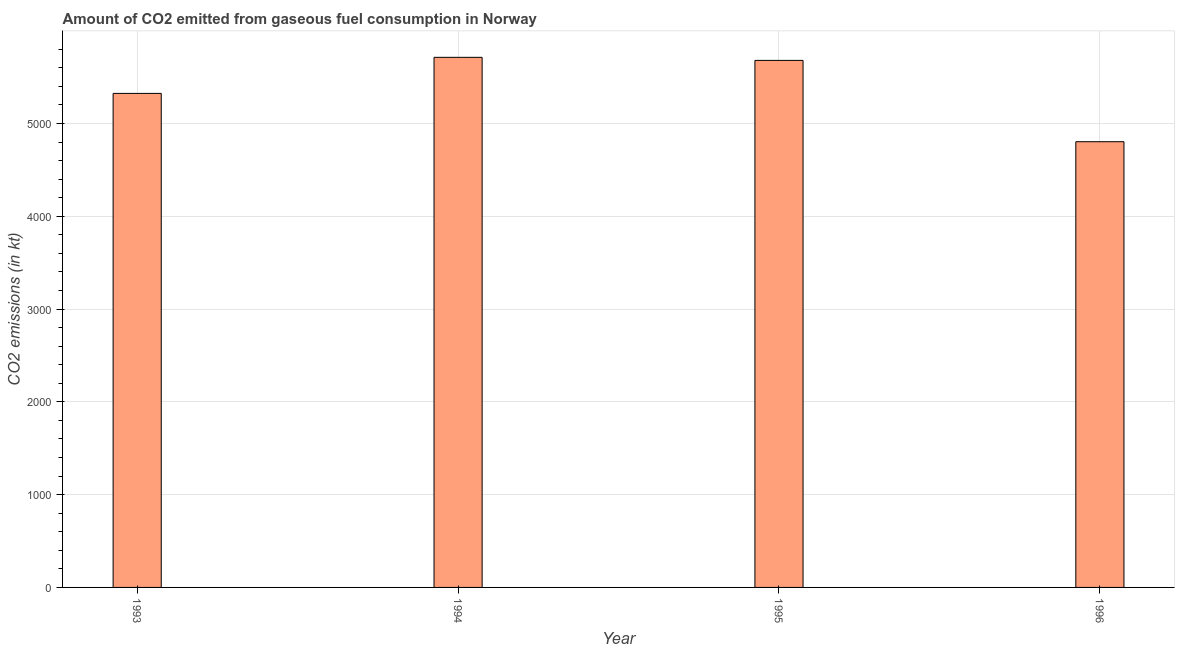What is the title of the graph?
Your response must be concise. Amount of CO2 emitted from gaseous fuel consumption in Norway. What is the label or title of the X-axis?
Offer a terse response. Year. What is the label or title of the Y-axis?
Ensure brevity in your answer.  CO2 emissions (in kt). What is the co2 emissions from gaseous fuel consumption in 1996?
Make the answer very short. 4803.77. Across all years, what is the maximum co2 emissions from gaseous fuel consumption?
Give a very brief answer. 5713.19. Across all years, what is the minimum co2 emissions from gaseous fuel consumption?
Offer a very short reply. 4803.77. In which year was the co2 emissions from gaseous fuel consumption maximum?
Ensure brevity in your answer.  1994. What is the sum of the co2 emissions from gaseous fuel consumption?
Your response must be concise. 2.15e+04. What is the difference between the co2 emissions from gaseous fuel consumption in 1993 and 1995?
Provide a succinct answer. -355.7. What is the average co2 emissions from gaseous fuel consumption per year?
Your answer should be compact. 5380.41. What is the median co2 emissions from gaseous fuel consumption?
Keep it short and to the point. 5502.33. In how many years, is the co2 emissions from gaseous fuel consumption greater than 400 kt?
Ensure brevity in your answer.  4. Do a majority of the years between 1995 and 1994 (inclusive) have co2 emissions from gaseous fuel consumption greater than 3400 kt?
Make the answer very short. No. What is the ratio of the co2 emissions from gaseous fuel consumption in 1993 to that in 1994?
Your answer should be compact. 0.93. Is the co2 emissions from gaseous fuel consumption in 1993 less than that in 1995?
Your answer should be very brief. Yes. What is the difference between the highest and the second highest co2 emissions from gaseous fuel consumption?
Offer a very short reply. 33. What is the difference between the highest and the lowest co2 emissions from gaseous fuel consumption?
Provide a succinct answer. 909.42. How many bars are there?
Offer a very short reply. 4. Are the values on the major ticks of Y-axis written in scientific E-notation?
Give a very brief answer. No. What is the CO2 emissions (in kt) in 1993?
Give a very brief answer. 5324.48. What is the CO2 emissions (in kt) of 1994?
Provide a short and direct response. 5713.19. What is the CO2 emissions (in kt) of 1995?
Your answer should be very brief. 5680.18. What is the CO2 emissions (in kt) in 1996?
Offer a terse response. 4803.77. What is the difference between the CO2 emissions (in kt) in 1993 and 1994?
Your answer should be very brief. -388.7. What is the difference between the CO2 emissions (in kt) in 1993 and 1995?
Ensure brevity in your answer.  -355.7. What is the difference between the CO2 emissions (in kt) in 1993 and 1996?
Your answer should be very brief. 520.71. What is the difference between the CO2 emissions (in kt) in 1994 and 1995?
Make the answer very short. 33. What is the difference between the CO2 emissions (in kt) in 1994 and 1996?
Make the answer very short. 909.42. What is the difference between the CO2 emissions (in kt) in 1995 and 1996?
Provide a succinct answer. 876.41. What is the ratio of the CO2 emissions (in kt) in 1993 to that in 1994?
Give a very brief answer. 0.93. What is the ratio of the CO2 emissions (in kt) in 1993 to that in 1995?
Keep it short and to the point. 0.94. What is the ratio of the CO2 emissions (in kt) in 1993 to that in 1996?
Give a very brief answer. 1.11. What is the ratio of the CO2 emissions (in kt) in 1994 to that in 1995?
Keep it short and to the point. 1.01. What is the ratio of the CO2 emissions (in kt) in 1994 to that in 1996?
Offer a very short reply. 1.19. What is the ratio of the CO2 emissions (in kt) in 1995 to that in 1996?
Your answer should be compact. 1.18. 